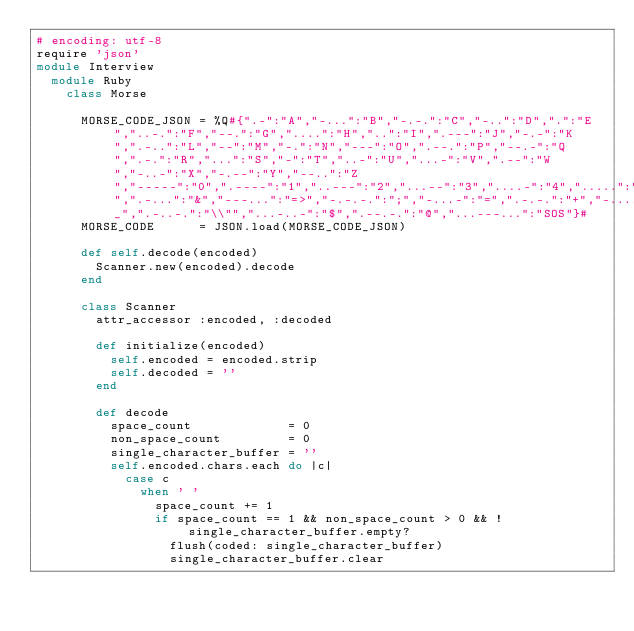Convert code to text. <code><loc_0><loc_0><loc_500><loc_500><_Ruby_># encoding: utf-8
require 'json'
module Interview
  module Ruby
    class Morse

      MORSE_CODE_JSON = %Q#{".-":"A","-...":"B","-.-.":"C","-..":"D",".":"E","..-.":"F","--.":"G","....":"H","..":"I",".---":"J","-.-":"K",".-..":"L","--":"M","-.":"N","---":"O",".--.":"P","--.-":"Q",".-.":"R","...":"S","-":"T","..-":"U","...-":"V",".--":"W","-..-":"X","-.--":"Y","--..":"Z","-----":"0",".----":"1","..---":"2","...--":"3","....-":"4",".....":"5","-....":"6","--...":"7","---..":"8","----.":"9",".-.-.-":".","--..--":",","..--..":"?",".----.":"'","-.-.--":"!","-..-.":"/","-.--.":"(","-.--.-":")",".-...":"&","---...":"=>","-.-.-.":";","-...-":"=",".-.-.":"+","-....-":"-","..--.-":"_",".-..-.":"\\"","...-..-":"$",".--.-.":"@","...---...":"SOS"}#
      MORSE_CODE      = JSON.load(MORSE_CODE_JSON)

      def self.decode(encoded)
        Scanner.new(encoded).decode
      end

      class Scanner
        attr_accessor :encoded, :decoded

        def initialize(encoded)
          self.encoded = encoded.strip
          self.decoded = ''
        end

        def decode
          space_count             = 0
          non_space_count         = 0
          single_character_buffer = ''
          self.encoded.chars.each do |c|
            case c
              when ' '
                space_count += 1
                if space_count == 1 && non_space_count > 0 && !single_character_buffer.empty?
                  flush(coded: single_character_buffer)
                  single_character_buffer.clear</code> 